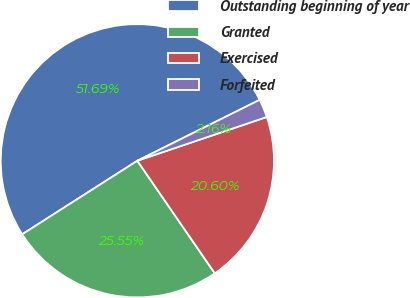<chart> <loc_0><loc_0><loc_500><loc_500><pie_chart><fcel>Outstanding beginning of year<fcel>Granted<fcel>Exercised<fcel>Forfeited<nl><fcel>51.7%<fcel>25.55%<fcel>20.6%<fcel>2.16%<nl></chart> 